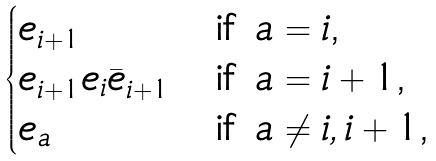<formula> <loc_0><loc_0><loc_500><loc_500>\begin{cases} e _ { i + 1 } & \text {if $a=i$,} \\ e _ { i + 1 } e _ { i } \bar { e } _ { i + 1 } & \text {if $a=i+1$,} \\ e _ { a } & \text {if $a\not= i,i+1$,} \end{cases}</formula> 